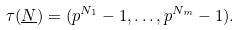<formula> <loc_0><loc_0><loc_500><loc_500>\tau ( \underline { N } ) = ( p ^ { N _ { 1 } } - 1 , \dots , p ^ { N _ { m } } - 1 ) .</formula> 